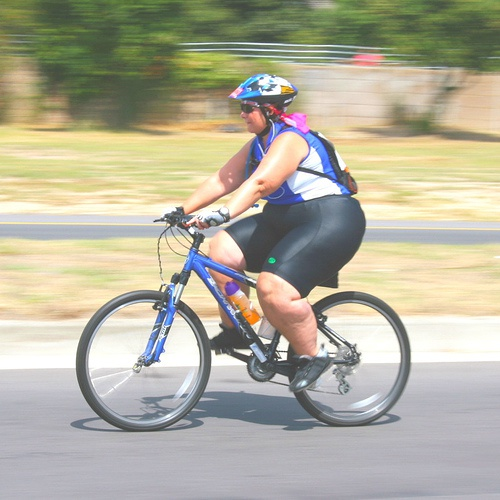Describe the objects in this image and their specific colors. I can see bicycle in olive, lightgray, gray, darkgray, and tan tones, people in olive, gray, ivory, and tan tones, and backpack in olive, gray, white, brown, and darkgray tones in this image. 